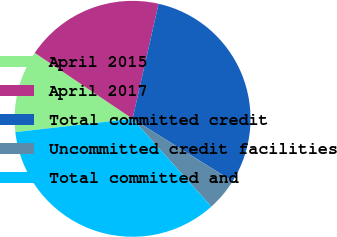Convert chart to OTSL. <chart><loc_0><loc_0><loc_500><loc_500><pie_chart><fcel>April 2015<fcel>April 2017<fcel>Total committed credit<fcel>Uncommitted credit facilities<fcel>Total committed and<nl><fcel>11.24%<fcel>19.1%<fcel>30.34%<fcel>4.49%<fcel>34.83%<nl></chart> 